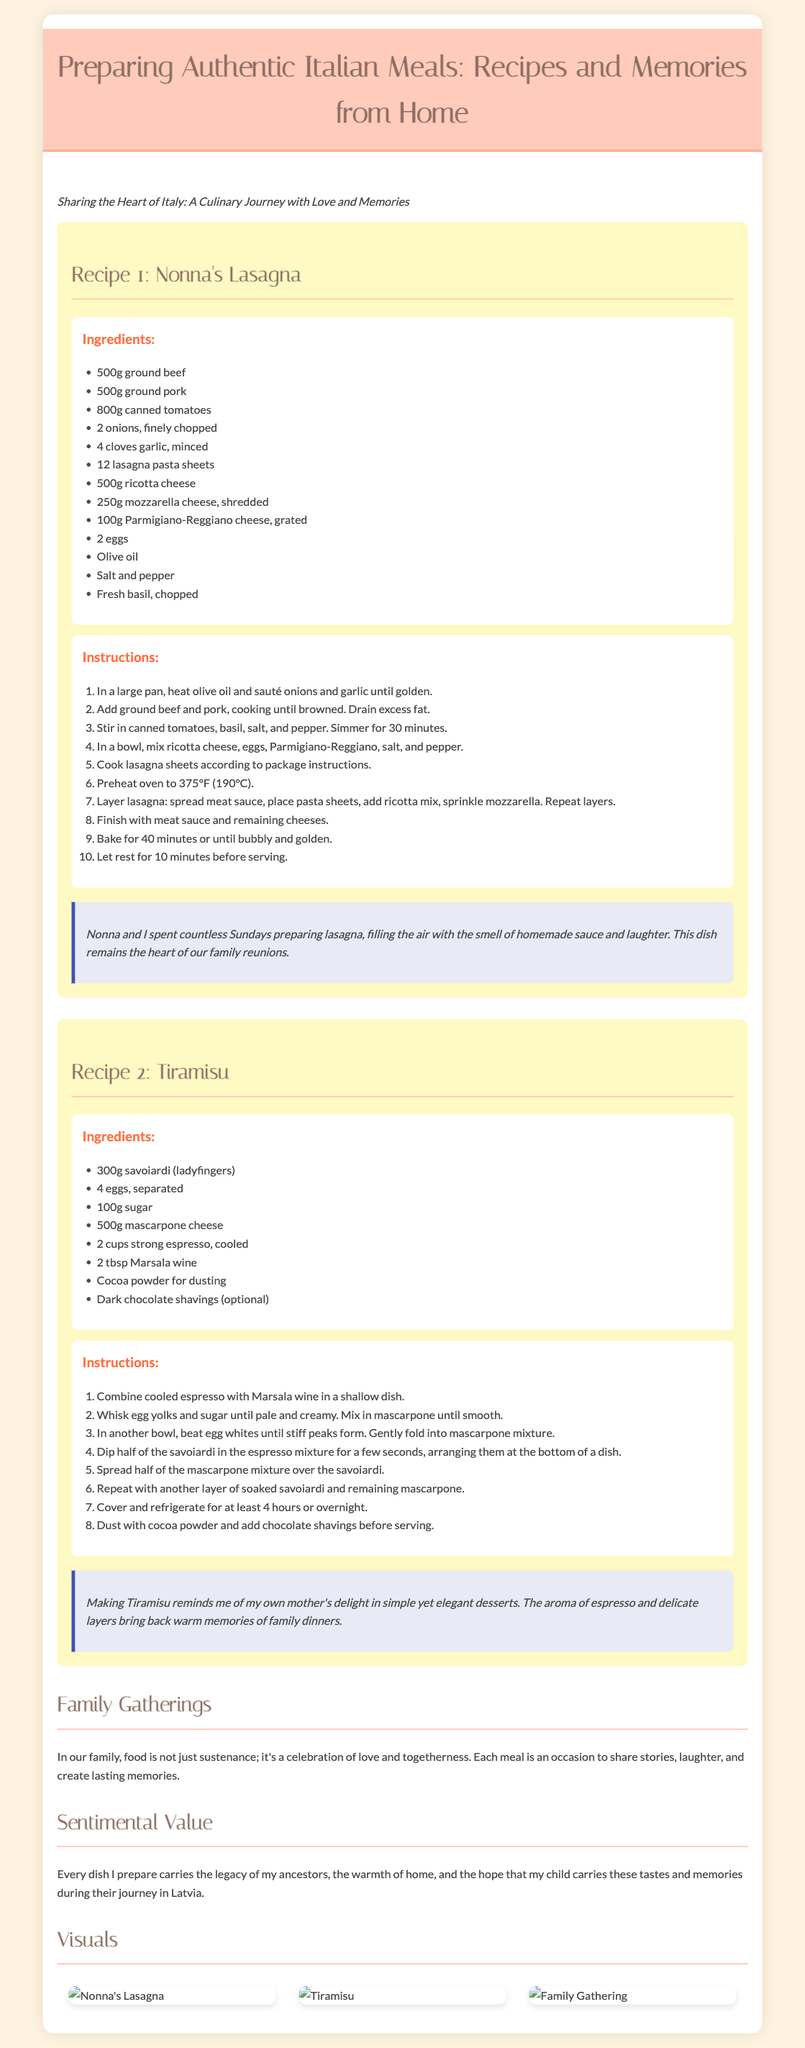What is the title of the presentation? The title of the presentation is the main heading showcasing the theme of the document.
Answer: Preparing Authentic Italian Meals: Recipes and Memories from Home How many ingredients are listed for Nonna's Lasagna? The document includes a list of various ingredients for Nonna's Lasagna in a section dedicated to it.
Answer: 12 What is the primary ingredient in Tiramisu? The primary ingredient in Tiramisu can be found in the list of ingredients provided for that recipe.
Answer: mascarpone cheese What is the baking temperature for Nonna's Lasagna? The document provides specific cooking information within the instructions for making Nonna's Lasagna.
Answer: 375°F (190°C) What does the anecdote about Tiramisu remind the author of? The anecdote explains feelings associated with preparing Tiramisu, reflecting on memories related to family functions.
Answer: mother's delight How many main recipes are presented? This refers to the number of distinct recipes highlighted in the document, each with its own section.
Answer: 2 What do family gatherings represent according to the document? The document explains the significance of family gatherings in relation to food and cultural practices.
Answer: love and togetherness What is the visual section of the document called? The section showcasing images related to the recipes is specifically labeled, revealing its focus.
Answer: Visuals 